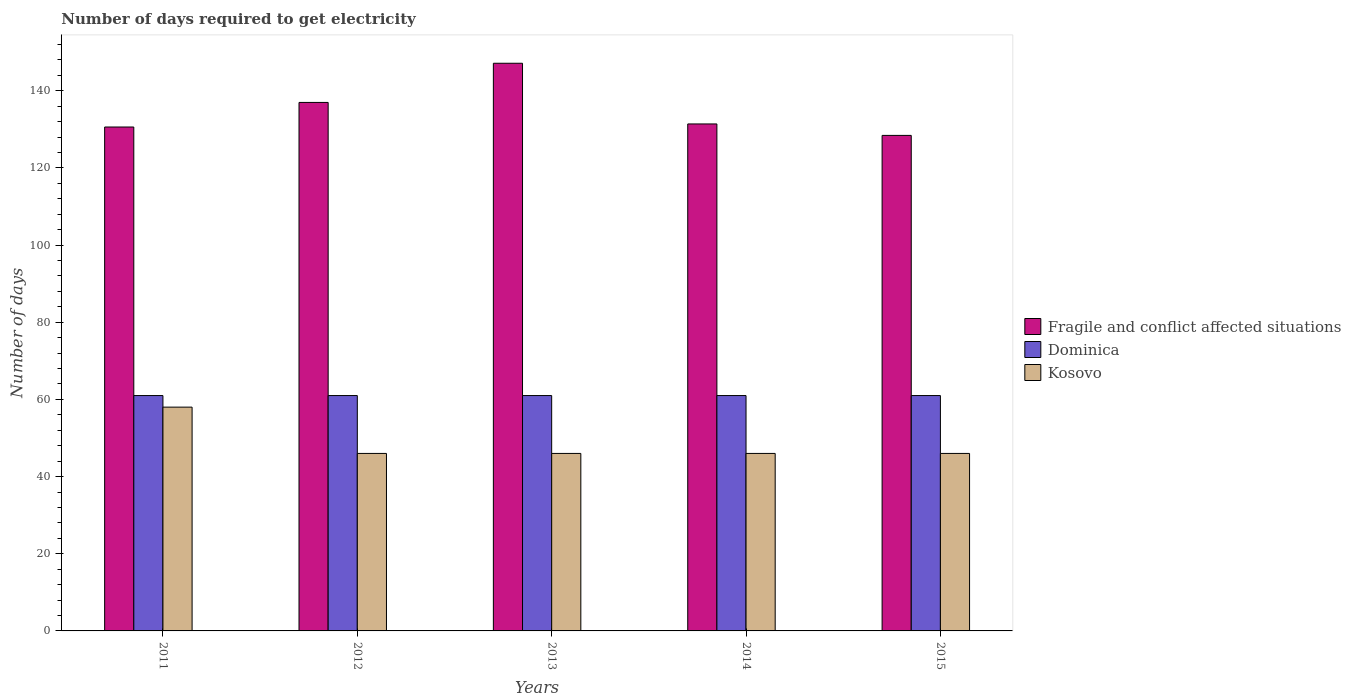How many different coloured bars are there?
Offer a terse response. 3. In how many cases, is the number of bars for a given year not equal to the number of legend labels?
Your answer should be compact. 0. What is the number of days required to get electricity in in Dominica in 2015?
Your response must be concise. 61. Across all years, what is the maximum number of days required to get electricity in in Kosovo?
Your answer should be very brief. 58. Across all years, what is the minimum number of days required to get electricity in in Kosovo?
Give a very brief answer. 46. In which year was the number of days required to get electricity in in Dominica maximum?
Provide a short and direct response. 2011. In which year was the number of days required to get electricity in in Fragile and conflict affected situations minimum?
Provide a short and direct response. 2015. What is the total number of days required to get electricity in in Fragile and conflict affected situations in the graph?
Ensure brevity in your answer.  674.51. What is the difference between the number of days required to get electricity in in Fragile and conflict affected situations in 2012 and that in 2015?
Offer a very short reply. 8.55. What is the difference between the number of days required to get electricity in in Kosovo in 2015 and the number of days required to get electricity in in Fragile and conflict affected situations in 2012?
Offer a terse response. -90.97. What is the average number of days required to get electricity in in Kosovo per year?
Your answer should be compact. 48.4. In the year 2014, what is the difference between the number of days required to get electricity in in Dominica and number of days required to get electricity in in Kosovo?
Give a very brief answer. 15. In how many years, is the number of days required to get electricity in in Dominica greater than 12 days?
Your response must be concise. 5. What is the ratio of the number of days required to get electricity in in Dominica in 2014 to that in 2015?
Your response must be concise. 1. Is the number of days required to get electricity in in Dominica in 2012 less than that in 2013?
Ensure brevity in your answer.  No. Is the difference between the number of days required to get electricity in in Dominica in 2011 and 2012 greater than the difference between the number of days required to get electricity in in Kosovo in 2011 and 2012?
Provide a short and direct response. No. What is the difference between the highest and the second highest number of days required to get electricity in in Fragile and conflict affected situations?
Offer a terse response. 10.15. What is the difference between the highest and the lowest number of days required to get electricity in in Kosovo?
Ensure brevity in your answer.  12. Is the sum of the number of days required to get electricity in in Dominica in 2011 and 2013 greater than the maximum number of days required to get electricity in in Fragile and conflict affected situations across all years?
Your answer should be very brief. No. What does the 1st bar from the left in 2015 represents?
Your answer should be very brief. Fragile and conflict affected situations. What does the 3rd bar from the right in 2013 represents?
Ensure brevity in your answer.  Fragile and conflict affected situations. How many bars are there?
Give a very brief answer. 15. What is the difference between two consecutive major ticks on the Y-axis?
Your answer should be very brief. 20. Does the graph contain any zero values?
Provide a succinct answer. No. Does the graph contain grids?
Offer a very short reply. No. Where does the legend appear in the graph?
Make the answer very short. Center right. How are the legend labels stacked?
Offer a very short reply. Vertical. What is the title of the graph?
Offer a very short reply. Number of days required to get electricity. Does "Montenegro" appear as one of the legend labels in the graph?
Your response must be concise. No. What is the label or title of the Y-axis?
Provide a short and direct response. Number of days. What is the Number of days in Fragile and conflict affected situations in 2011?
Offer a very short reply. 130.6. What is the Number of days in Dominica in 2011?
Your answer should be very brief. 61. What is the Number of days of Fragile and conflict affected situations in 2012?
Provide a short and direct response. 136.97. What is the Number of days of Dominica in 2012?
Your answer should be compact. 61. What is the Number of days in Kosovo in 2012?
Make the answer very short. 46. What is the Number of days of Fragile and conflict affected situations in 2013?
Your answer should be very brief. 147.12. What is the Number of days of Dominica in 2013?
Provide a short and direct response. 61. What is the Number of days of Fragile and conflict affected situations in 2014?
Your answer should be compact. 131.39. What is the Number of days in Dominica in 2014?
Your answer should be compact. 61. What is the Number of days in Fragile and conflict affected situations in 2015?
Your response must be concise. 128.42. What is the Number of days of Kosovo in 2015?
Your answer should be very brief. 46. Across all years, what is the maximum Number of days in Fragile and conflict affected situations?
Offer a very short reply. 147.12. Across all years, what is the maximum Number of days of Dominica?
Give a very brief answer. 61. Across all years, what is the minimum Number of days in Fragile and conflict affected situations?
Offer a terse response. 128.42. What is the total Number of days in Fragile and conflict affected situations in the graph?
Provide a short and direct response. 674.51. What is the total Number of days of Dominica in the graph?
Your answer should be very brief. 305. What is the total Number of days of Kosovo in the graph?
Keep it short and to the point. 242. What is the difference between the Number of days of Fragile and conflict affected situations in 2011 and that in 2012?
Ensure brevity in your answer.  -6.37. What is the difference between the Number of days in Kosovo in 2011 and that in 2012?
Offer a very short reply. 12. What is the difference between the Number of days of Fragile and conflict affected situations in 2011 and that in 2013?
Provide a short and direct response. -16.52. What is the difference between the Number of days in Fragile and conflict affected situations in 2011 and that in 2014?
Your answer should be compact. -0.79. What is the difference between the Number of days in Dominica in 2011 and that in 2014?
Provide a short and direct response. 0. What is the difference between the Number of days in Kosovo in 2011 and that in 2014?
Your answer should be very brief. 12. What is the difference between the Number of days of Fragile and conflict affected situations in 2011 and that in 2015?
Provide a succinct answer. 2.18. What is the difference between the Number of days of Dominica in 2011 and that in 2015?
Provide a succinct answer. 0. What is the difference between the Number of days in Fragile and conflict affected situations in 2012 and that in 2013?
Your answer should be very brief. -10.15. What is the difference between the Number of days in Kosovo in 2012 and that in 2013?
Make the answer very short. 0. What is the difference between the Number of days in Fragile and conflict affected situations in 2012 and that in 2014?
Ensure brevity in your answer.  5.58. What is the difference between the Number of days of Fragile and conflict affected situations in 2012 and that in 2015?
Provide a succinct answer. 8.55. What is the difference between the Number of days in Dominica in 2012 and that in 2015?
Give a very brief answer. 0. What is the difference between the Number of days of Fragile and conflict affected situations in 2013 and that in 2014?
Give a very brief answer. 15.73. What is the difference between the Number of days in Dominica in 2013 and that in 2014?
Your answer should be very brief. 0. What is the difference between the Number of days of Kosovo in 2013 and that in 2014?
Give a very brief answer. 0. What is the difference between the Number of days in Fragile and conflict affected situations in 2013 and that in 2015?
Provide a short and direct response. 18.7. What is the difference between the Number of days in Fragile and conflict affected situations in 2014 and that in 2015?
Your answer should be very brief. 2.97. What is the difference between the Number of days of Fragile and conflict affected situations in 2011 and the Number of days of Dominica in 2012?
Your response must be concise. 69.6. What is the difference between the Number of days of Fragile and conflict affected situations in 2011 and the Number of days of Kosovo in 2012?
Provide a short and direct response. 84.6. What is the difference between the Number of days in Fragile and conflict affected situations in 2011 and the Number of days in Dominica in 2013?
Make the answer very short. 69.6. What is the difference between the Number of days of Fragile and conflict affected situations in 2011 and the Number of days of Kosovo in 2013?
Ensure brevity in your answer.  84.6. What is the difference between the Number of days of Fragile and conflict affected situations in 2011 and the Number of days of Dominica in 2014?
Offer a terse response. 69.6. What is the difference between the Number of days of Fragile and conflict affected situations in 2011 and the Number of days of Kosovo in 2014?
Keep it short and to the point. 84.6. What is the difference between the Number of days in Dominica in 2011 and the Number of days in Kosovo in 2014?
Your answer should be very brief. 15. What is the difference between the Number of days in Fragile and conflict affected situations in 2011 and the Number of days in Dominica in 2015?
Your answer should be compact. 69.6. What is the difference between the Number of days of Fragile and conflict affected situations in 2011 and the Number of days of Kosovo in 2015?
Offer a very short reply. 84.6. What is the difference between the Number of days of Dominica in 2011 and the Number of days of Kosovo in 2015?
Offer a very short reply. 15. What is the difference between the Number of days of Fragile and conflict affected situations in 2012 and the Number of days of Dominica in 2013?
Provide a short and direct response. 75.97. What is the difference between the Number of days of Fragile and conflict affected situations in 2012 and the Number of days of Kosovo in 2013?
Your response must be concise. 90.97. What is the difference between the Number of days of Fragile and conflict affected situations in 2012 and the Number of days of Dominica in 2014?
Ensure brevity in your answer.  75.97. What is the difference between the Number of days of Fragile and conflict affected situations in 2012 and the Number of days of Kosovo in 2014?
Offer a terse response. 90.97. What is the difference between the Number of days of Fragile and conflict affected situations in 2012 and the Number of days of Dominica in 2015?
Keep it short and to the point. 75.97. What is the difference between the Number of days of Fragile and conflict affected situations in 2012 and the Number of days of Kosovo in 2015?
Provide a succinct answer. 90.97. What is the difference between the Number of days in Fragile and conflict affected situations in 2013 and the Number of days in Dominica in 2014?
Your response must be concise. 86.12. What is the difference between the Number of days in Fragile and conflict affected situations in 2013 and the Number of days in Kosovo in 2014?
Your answer should be compact. 101.12. What is the difference between the Number of days in Dominica in 2013 and the Number of days in Kosovo in 2014?
Your answer should be very brief. 15. What is the difference between the Number of days in Fragile and conflict affected situations in 2013 and the Number of days in Dominica in 2015?
Provide a succinct answer. 86.12. What is the difference between the Number of days in Fragile and conflict affected situations in 2013 and the Number of days in Kosovo in 2015?
Your answer should be very brief. 101.12. What is the difference between the Number of days of Dominica in 2013 and the Number of days of Kosovo in 2015?
Your response must be concise. 15. What is the difference between the Number of days of Fragile and conflict affected situations in 2014 and the Number of days of Dominica in 2015?
Keep it short and to the point. 70.39. What is the difference between the Number of days in Fragile and conflict affected situations in 2014 and the Number of days in Kosovo in 2015?
Make the answer very short. 85.39. What is the average Number of days of Fragile and conflict affected situations per year?
Provide a short and direct response. 134.9. What is the average Number of days of Kosovo per year?
Your answer should be very brief. 48.4. In the year 2011, what is the difference between the Number of days in Fragile and conflict affected situations and Number of days in Dominica?
Offer a terse response. 69.6. In the year 2011, what is the difference between the Number of days in Fragile and conflict affected situations and Number of days in Kosovo?
Give a very brief answer. 72.6. In the year 2012, what is the difference between the Number of days in Fragile and conflict affected situations and Number of days in Dominica?
Make the answer very short. 75.97. In the year 2012, what is the difference between the Number of days in Fragile and conflict affected situations and Number of days in Kosovo?
Keep it short and to the point. 90.97. In the year 2012, what is the difference between the Number of days in Dominica and Number of days in Kosovo?
Your answer should be very brief. 15. In the year 2013, what is the difference between the Number of days of Fragile and conflict affected situations and Number of days of Dominica?
Your answer should be compact. 86.12. In the year 2013, what is the difference between the Number of days in Fragile and conflict affected situations and Number of days in Kosovo?
Keep it short and to the point. 101.12. In the year 2014, what is the difference between the Number of days in Fragile and conflict affected situations and Number of days in Dominica?
Keep it short and to the point. 70.39. In the year 2014, what is the difference between the Number of days of Fragile and conflict affected situations and Number of days of Kosovo?
Offer a very short reply. 85.39. In the year 2014, what is the difference between the Number of days of Dominica and Number of days of Kosovo?
Your answer should be compact. 15. In the year 2015, what is the difference between the Number of days of Fragile and conflict affected situations and Number of days of Dominica?
Provide a succinct answer. 67.42. In the year 2015, what is the difference between the Number of days in Fragile and conflict affected situations and Number of days in Kosovo?
Make the answer very short. 82.42. In the year 2015, what is the difference between the Number of days in Dominica and Number of days in Kosovo?
Give a very brief answer. 15. What is the ratio of the Number of days in Fragile and conflict affected situations in 2011 to that in 2012?
Offer a terse response. 0.95. What is the ratio of the Number of days in Dominica in 2011 to that in 2012?
Your answer should be very brief. 1. What is the ratio of the Number of days of Kosovo in 2011 to that in 2012?
Provide a short and direct response. 1.26. What is the ratio of the Number of days in Fragile and conflict affected situations in 2011 to that in 2013?
Provide a succinct answer. 0.89. What is the ratio of the Number of days of Dominica in 2011 to that in 2013?
Make the answer very short. 1. What is the ratio of the Number of days of Kosovo in 2011 to that in 2013?
Offer a very short reply. 1.26. What is the ratio of the Number of days in Fragile and conflict affected situations in 2011 to that in 2014?
Provide a short and direct response. 0.99. What is the ratio of the Number of days of Kosovo in 2011 to that in 2014?
Make the answer very short. 1.26. What is the ratio of the Number of days in Fragile and conflict affected situations in 2011 to that in 2015?
Offer a very short reply. 1.02. What is the ratio of the Number of days in Kosovo in 2011 to that in 2015?
Your answer should be very brief. 1.26. What is the ratio of the Number of days in Kosovo in 2012 to that in 2013?
Keep it short and to the point. 1. What is the ratio of the Number of days of Fragile and conflict affected situations in 2012 to that in 2014?
Make the answer very short. 1.04. What is the ratio of the Number of days of Dominica in 2012 to that in 2014?
Your answer should be compact. 1. What is the ratio of the Number of days of Fragile and conflict affected situations in 2012 to that in 2015?
Provide a short and direct response. 1.07. What is the ratio of the Number of days of Dominica in 2012 to that in 2015?
Give a very brief answer. 1. What is the ratio of the Number of days in Fragile and conflict affected situations in 2013 to that in 2014?
Make the answer very short. 1.12. What is the ratio of the Number of days in Fragile and conflict affected situations in 2013 to that in 2015?
Ensure brevity in your answer.  1.15. What is the ratio of the Number of days in Dominica in 2013 to that in 2015?
Make the answer very short. 1. What is the ratio of the Number of days of Kosovo in 2013 to that in 2015?
Keep it short and to the point. 1. What is the ratio of the Number of days in Fragile and conflict affected situations in 2014 to that in 2015?
Your response must be concise. 1.02. What is the ratio of the Number of days in Kosovo in 2014 to that in 2015?
Offer a terse response. 1. What is the difference between the highest and the second highest Number of days of Fragile and conflict affected situations?
Keep it short and to the point. 10.15. What is the difference between the highest and the second highest Number of days in Kosovo?
Provide a short and direct response. 12. What is the difference between the highest and the lowest Number of days in Fragile and conflict affected situations?
Keep it short and to the point. 18.7. What is the difference between the highest and the lowest Number of days of Dominica?
Your response must be concise. 0. 